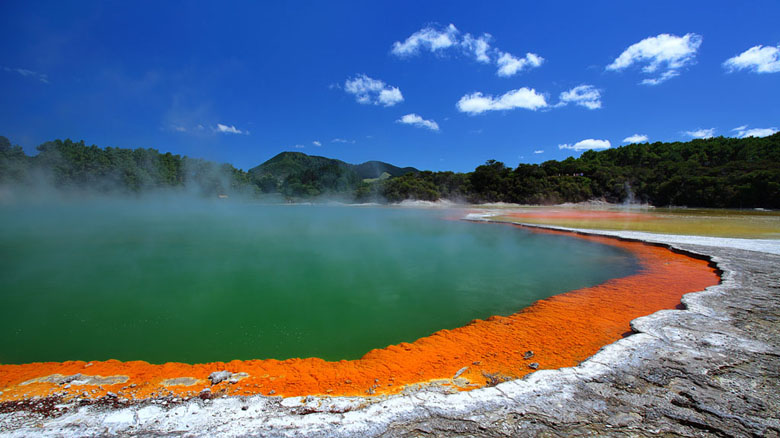Describe the following image. The image captures the vibrant and surreal beauty of the Wai-O-Tapu Thermal Wonderland located in Rotorua, New Zealand. Dominating the frame is a large geothermal hot spring, featuring a stunning palette of colors that perfectly showcases the area's geothermal activity. The edges of the spring are framed by bright orange hues, due to the rich deposits of minerals such as sulfur, which gradually transition into deep green waters at the center. This remarkable gradient creates a mesmerizing visual spectacle.

There are wisps of steam rising from the surface of the water, emphasizing the high geothermal activity underlying this picturesque scene. Surrounding the hot spring is a white and gray crust, indicative of the high mineral content. Beyond the spring, the landscape transitions into lush greenery, with scattered trees meeting the horizon. In the distance, towering mountains complete the scene, their peaks merging with a clear, azure sky, dotted with a few fluffy white clouds.

The photograph is taken from a ground-level perspective, looking across the hot spring toward the mountains, allowing for a comprehensive view that spans from the vivid waters in the foreground to the majestic mountains in the background. It is a captivating snapshot that brilliantly captures the unique, natural beauty of New Zealand's geothermal wonders. 